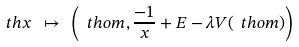<formula> <loc_0><loc_0><loc_500><loc_500>\ t h x \ \mapsto \ \left ( \ t h o m , \frac { - 1 } { x } + E - \lambda V ( \ t h o m ) \right ) \</formula> 